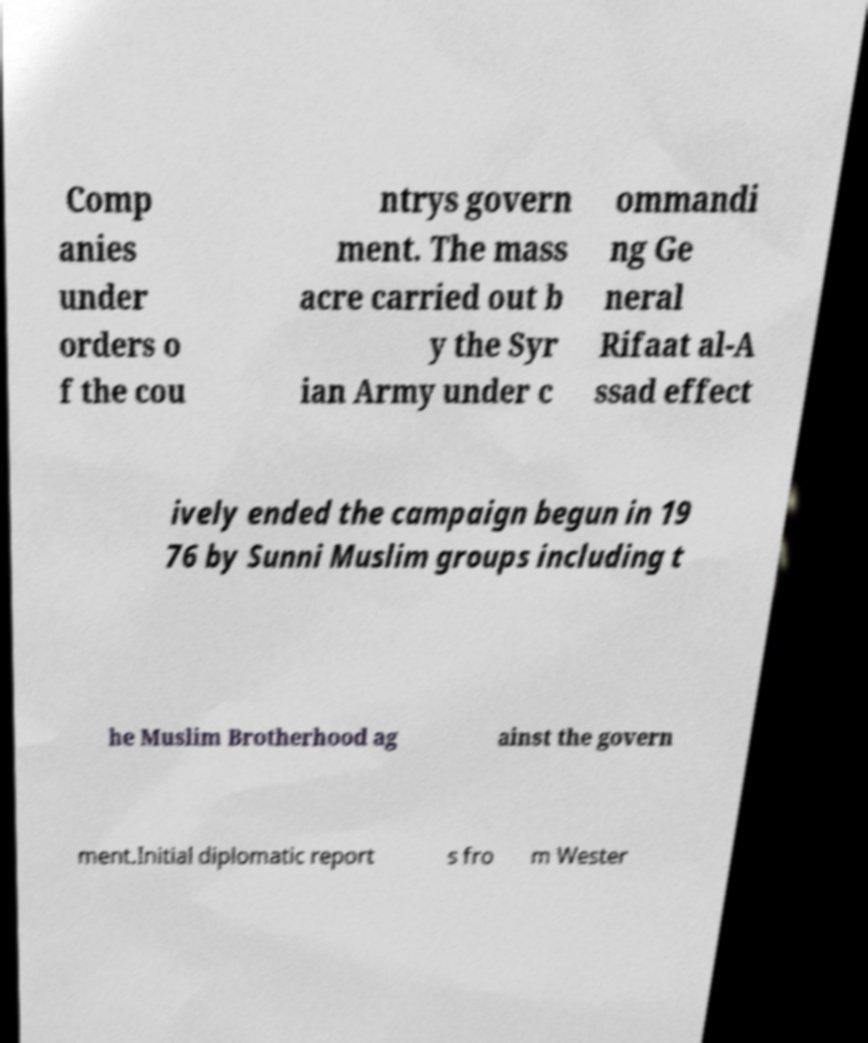Could you extract and type out the text from this image? Comp anies under orders o f the cou ntrys govern ment. The mass acre carried out b y the Syr ian Army under c ommandi ng Ge neral Rifaat al-A ssad effect ively ended the campaign begun in 19 76 by Sunni Muslim groups including t he Muslim Brotherhood ag ainst the govern ment.Initial diplomatic report s fro m Wester 